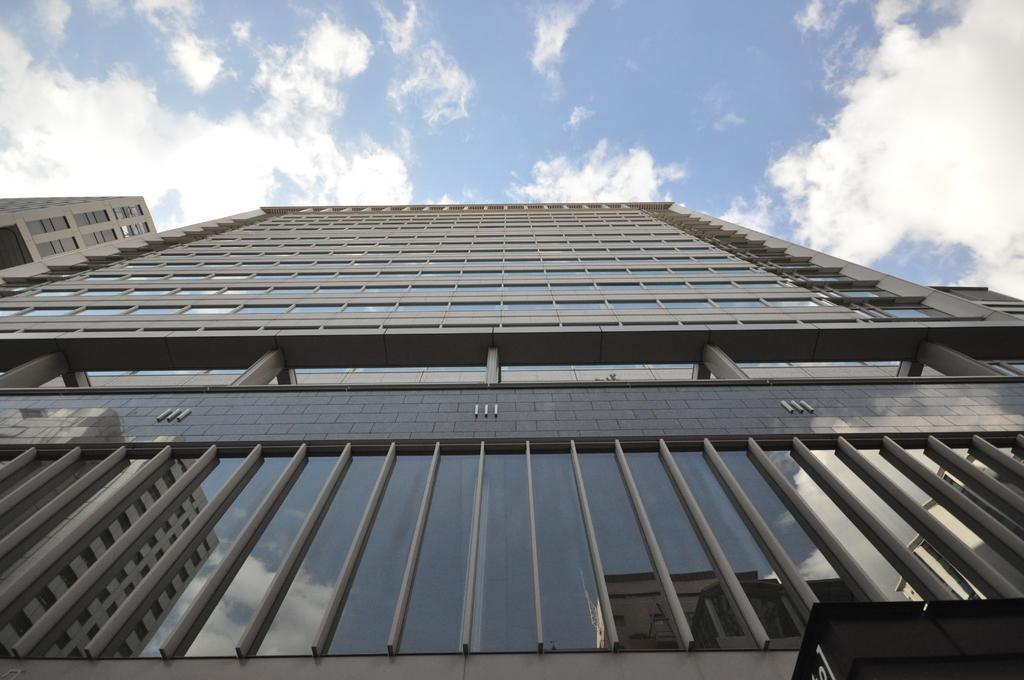What type of structures can be seen in the image? There are buildings in the image. What can be observed in the sky in the image? There are clouds in the sky in the image. How many shoes can be seen in the image? There are no shoes present in the image. What is the image doing to the viewer's mind? The image itself does not have the ability to directly affect the viewer's mind; it is a visual representation that can be interpreted and processed by the viewer's mind. 